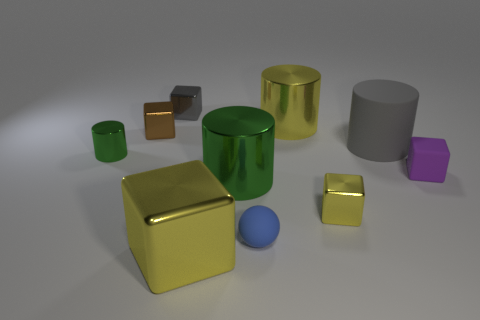Subtract all big cylinders. How many cylinders are left? 1 Subtract all green cylinders. How many cylinders are left? 2 Subtract all yellow cylinders. How many yellow blocks are left? 2 Subtract all balls. How many objects are left? 9 Subtract all cyan spheres. Subtract all blue blocks. How many spheres are left? 1 Subtract all cylinders. Subtract all small green cylinders. How many objects are left? 5 Add 3 metallic cubes. How many metallic cubes are left? 7 Add 2 small shiny blocks. How many small shiny blocks exist? 5 Subtract 0 red spheres. How many objects are left? 10 Subtract 1 balls. How many balls are left? 0 